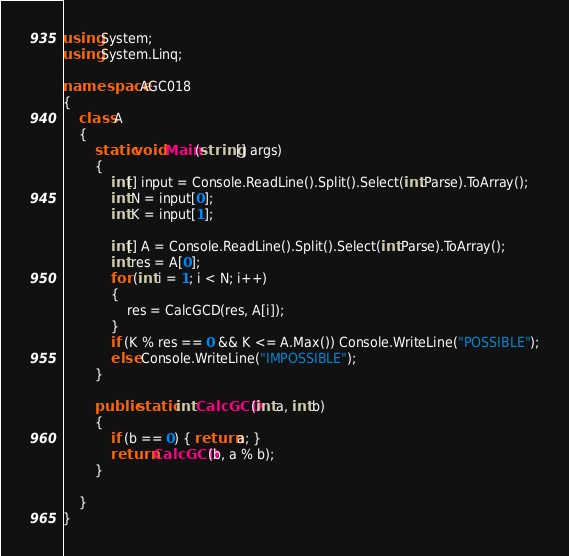<code> <loc_0><loc_0><loc_500><loc_500><_C#_>using System;
using System.Linq;

namespace AGC018
{
    class A
    {
        static void Main(string[] args)
        {
            int[] input = Console.ReadLine().Split().Select(int.Parse).ToArray();
            int N = input[0];
            int K = input[1];

            int[] A = Console.ReadLine().Split().Select(int.Parse).ToArray();
            int res = A[0];
            for (int i = 1; i < N; i++)
            {
                res = CalcGCD(res, A[i]);
            }
            if (K % res == 0 && K <= A.Max()) Console.WriteLine("POSSIBLE");
            else Console.WriteLine("IMPOSSIBLE");
        }

        public static int CalcGCD(int a, int b)
        {
            if (b == 0) { return a; }
            return CalcGCD(b, a % b);
        }

    }
}
</code> 